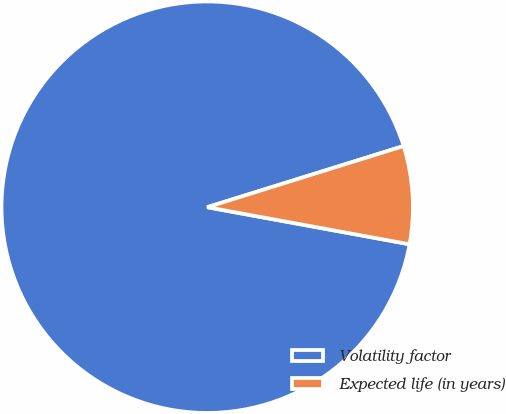<chart> <loc_0><loc_0><loc_500><loc_500><pie_chart><fcel>Volatility factor<fcel>Expected life (in years)<nl><fcel>92.31%<fcel>7.69%<nl></chart> 